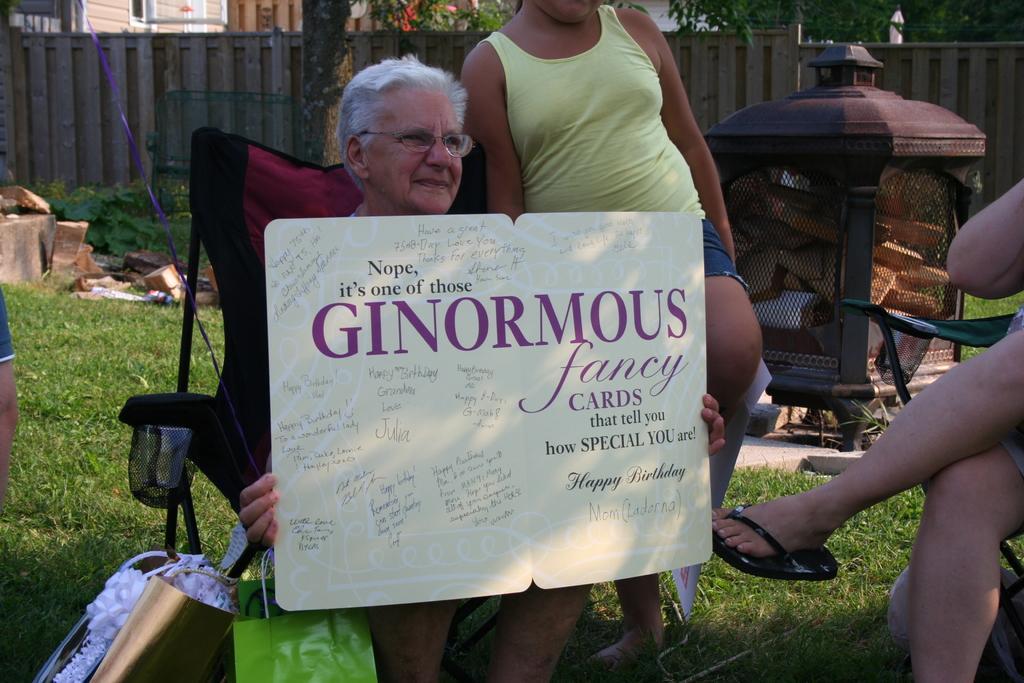Describe this image in one or two sentences. In this image there is a woman holding a placard in her hand, inside the woman there is a girl standing, in the background of the image there is grass on the surface and there is a wooden fence, on the other side of the wooden fence there are trees and building. 